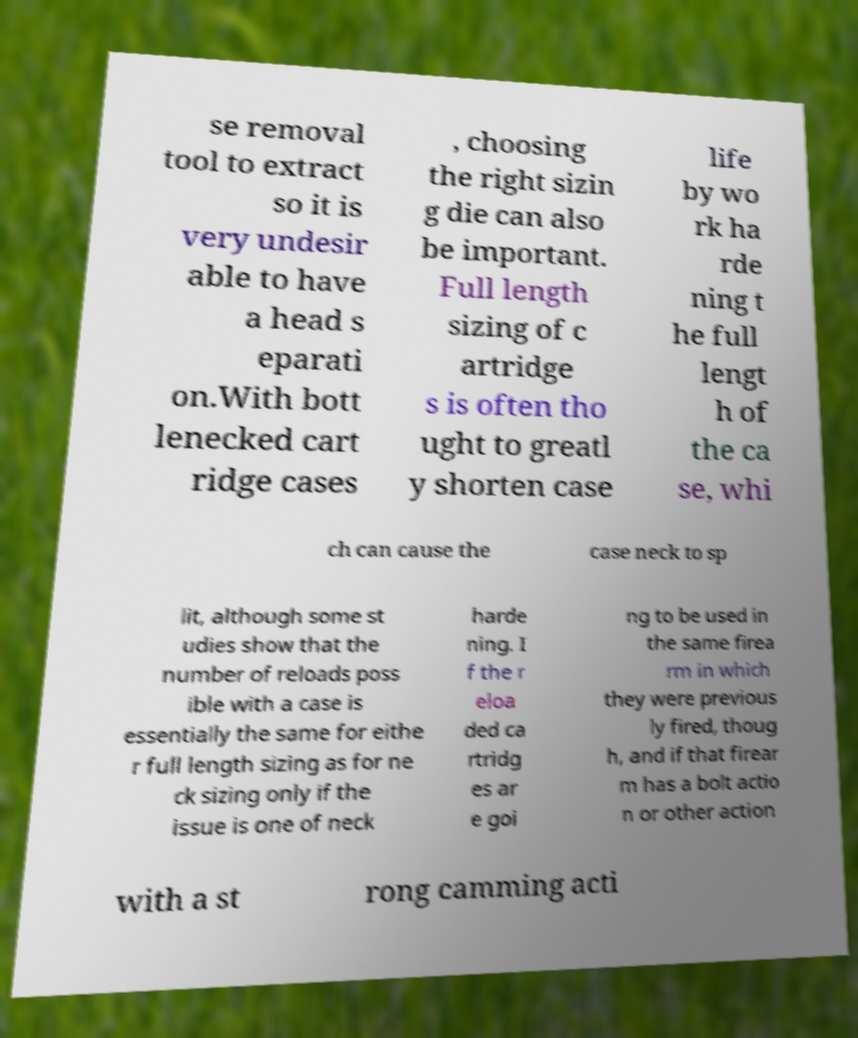Could you assist in decoding the text presented in this image and type it out clearly? se removal tool to extract so it is very undesir able to have a head s eparati on.With bott lenecked cart ridge cases , choosing the right sizin g die can also be important. Full length sizing of c artridge s is often tho ught to greatl y shorten case life by wo rk ha rde ning t he full lengt h of the ca se, whi ch can cause the case neck to sp lit, although some st udies show that the number of reloads poss ible with a case is essentially the same for eithe r full length sizing as for ne ck sizing only if the issue is one of neck harde ning. I f the r eloa ded ca rtridg es ar e goi ng to be used in the same firea rm in which they were previous ly fired, thoug h, and if that firear m has a bolt actio n or other action with a st rong camming acti 